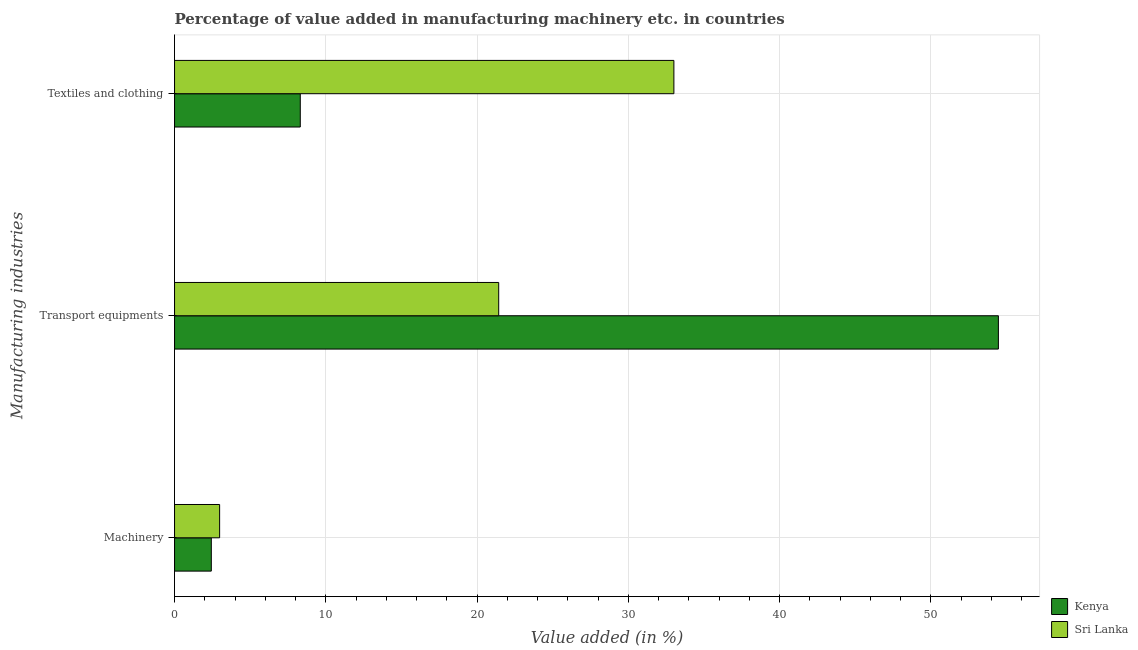How many groups of bars are there?
Your answer should be compact. 3. Are the number of bars per tick equal to the number of legend labels?
Give a very brief answer. Yes. What is the label of the 3rd group of bars from the top?
Offer a very short reply. Machinery. What is the value added in manufacturing transport equipments in Kenya?
Provide a short and direct response. 54.47. Across all countries, what is the maximum value added in manufacturing transport equipments?
Offer a terse response. 54.47. Across all countries, what is the minimum value added in manufacturing transport equipments?
Ensure brevity in your answer.  21.43. In which country was the value added in manufacturing transport equipments maximum?
Offer a terse response. Kenya. In which country was the value added in manufacturing transport equipments minimum?
Your answer should be compact. Sri Lanka. What is the total value added in manufacturing transport equipments in the graph?
Keep it short and to the point. 75.9. What is the difference between the value added in manufacturing transport equipments in Sri Lanka and that in Kenya?
Your answer should be compact. -33.04. What is the difference between the value added in manufacturing textile and clothing in Kenya and the value added in manufacturing machinery in Sri Lanka?
Your response must be concise. 5.33. What is the average value added in manufacturing textile and clothing per country?
Your answer should be compact. 20.66. What is the difference between the value added in manufacturing textile and clothing and value added in manufacturing machinery in Kenya?
Ensure brevity in your answer.  5.88. In how many countries, is the value added in manufacturing textile and clothing greater than 38 %?
Provide a succinct answer. 0. What is the ratio of the value added in manufacturing machinery in Sri Lanka to that in Kenya?
Your answer should be very brief. 1.23. Is the value added in manufacturing machinery in Sri Lanka less than that in Kenya?
Ensure brevity in your answer.  No. Is the difference between the value added in manufacturing textile and clothing in Sri Lanka and Kenya greater than the difference between the value added in manufacturing transport equipments in Sri Lanka and Kenya?
Offer a very short reply. Yes. What is the difference between the highest and the second highest value added in manufacturing machinery?
Make the answer very short. 0.55. What is the difference between the highest and the lowest value added in manufacturing transport equipments?
Your answer should be very brief. 33.04. Is the sum of the value added in manufacturing machinery in Sri Lanka and Kenya greater than the maximum value added in manufacturing transport equipments across all countries?
Your answer should be compact. No. What does the 1st bar from the top in Machinery represents?
Your answer should be very brief. Sri Lanka. What does the 1st bar from the bottom in Machinery represents?
Offer a terse response. Kenya. How many bars are there?
Your answer should be compact. 6. What is the difference between two consecutive major ticks on the X-axis?
Provide a succinct answer. 10. Are the values on the major ticks of X-axis written in scientific E-notation?
Offer a very short reply. No. Does the graph contain grids?
Give a very brief answer. Yes. How many legend labels are there?
Offer a terse response. 2. What is the title of the graph?
Provide a succinct answer. Percentage of value added in manufacturing machinery etc. in countries. Does "Equatorial Guinea" appear as one of the legend labels in the graph?
Offer a very short reply. No. What is the label or title of the X-axis?
Give a very brief answer. Value added (in %). What is the label or title of the Y-axis?
Ensure brevity in your answer.  Manufacturing industries. What is the Value added (in %) in Kenya in Machinery?
Provide a short and direct response. 2.43. What is the Value added (in %) in Sri Lanka in Machinery?
Your response must be concise. 2.98. What is the Value added (in %) of Kenya in Transport equipments?
Your response must be concise. 54.47. What is the Value added (in %) of Sri Lanka in Transport equipments?
Make the answer very short. 21.43. What is the Value added (in %) of Kenya in Textiles and clothing?
Your answer should be very brief. 8.31. What is the Value added (in %) in Sri Lanka in Textiles and clothing?
Your answer should be compact. 33.01. Across all Manufacturing industries, what is the maximum Value added (in %) of Kenya?
Offer a very short reply. 54.47. Across all Manufacturing industries, what is the maximum Value added (in %) of Sri Lanka?
Ensure brevity in your answer.  33.01. Across all Manufacturing industries, what is the minimum Value added (in %) of Kenya?
Provide a short and direct response. 2.43. Across all Manufacturing industries, what is the minimum Value added (in %) in Sri Lanka?
Ensure brevity in your answer.  2.98. What is the total Value added (in %) in Kenya in the graph?
Offer a very short reply. 65.21. What is the total Value added (in %) of Sri Lanka in the graph?
Your answer should be very brief. 57.43. What is the difference between the Value added (in %) in Kenya in Machinery and that in Transport equipments?
Give a very brief answer. -52.04. What is the difference between the Value added (in %) of Sri Lanka in Machinery and that in Transport equipments?
Provide a short and direct response. -18.45. What is the difference between the Value added (in %) in Kenya in Machinery and that in Textiles and clothing?
Your response must be concise. -5.88. What is the difference between the Value added (in %) of Sri Lanka in Machinery and that in Textiles and clothing?
Provide a short and direct response. -30.04. What is the difference between the Value added (in %) in Kenya in Transport equipments and that in Textiles and clothing?
Give a very brief answer. 46.16. What is the difference between the Value added (in %) of Sri Lanka in Transport equipments and that in Textiles and clothing?
Your response must be concise. -11.58. What is the difference between the Value added (in %) of Kenya in Machinery and the Value added (in %) of Sri Lanka in Transport equipments?
Offer a very short reply. -19. What is the difference between the Value added (in %) in Kenya in Machinery and the Value added (in %) in Sri Lanka in Textiles and clothing?
Give a very brief answer. -30.58. What is the difference between the Value added (in %) of Kenya in Transport equipments and the Value added (in %) of Sri Lanka in Textiles and clothing?
Provide a short and direct response. 21.45. What is the average Value added (in %) in Kenya per Manufacturing industries?
Make the answer very short. 21.74. What is the average Value added (in %) in Sri Lanka per Manufacturing industries?
Provide a short and direct response. 19.14. What is the difference between the Value added (in %) of Kenya and Value added (in %) of Sri Lanka in Machinery?
Offer a very short reply. -0.55. What is the difference between the Value added (in %) of Kenya and Value added (in %) of Sri Lanka in Transport equipments?
Ensure brevity in your answer.  33.04. What is the difference between the Value added (in %) in Kenya and Value added (in %) in Sri Lanka in Textiles and clothing?
Provide a short and direct response. -24.7. What is the ratio of the Value added (in %) in Kenya in Machinery to that in Transport equipments?
Your response must be concise. 0.04. What is the ratio of the Value added (in %) of Sri Lanka in Machinery to that in Transport equipments?
Make the answer very short. 0.14. What is the ratio of the Value added (in %) of Kenya in Machinery to that in Textiles and clothing?
Your answer should be compact. 0.29. What is the ratio of the Value added (in %) in Sri Lanka in Machinery to that in Textiles and clothing?
Provide a short and direct response. 0.09. What is the ratio of the Value added (in %) of Kenya in Transport equipments to that in Textiles and clothing?
Offer a very short reply. 6.55. What is the ratio of the Value added (in %) in Sri Lanka in Transport equipments to that in Textiles and clothing?
Keep it short and to the point. 0.65. What is the difference between the highest and the second highest Value added (in %) of Kenya?
Provide a short and direct response. 46.16. What is the difference between the highest and the second highest Value added (in %) of Sri Lanka?
Make the answer very short. 11.58. What is the difference between the highest and the lowest Value added (in %) in Kenya?
Your answer should be compact. 52.04. What is the difference between the highest and the lowest Value added (in %) of Sri Lanka?
Your answer should be compact. 30.04. 